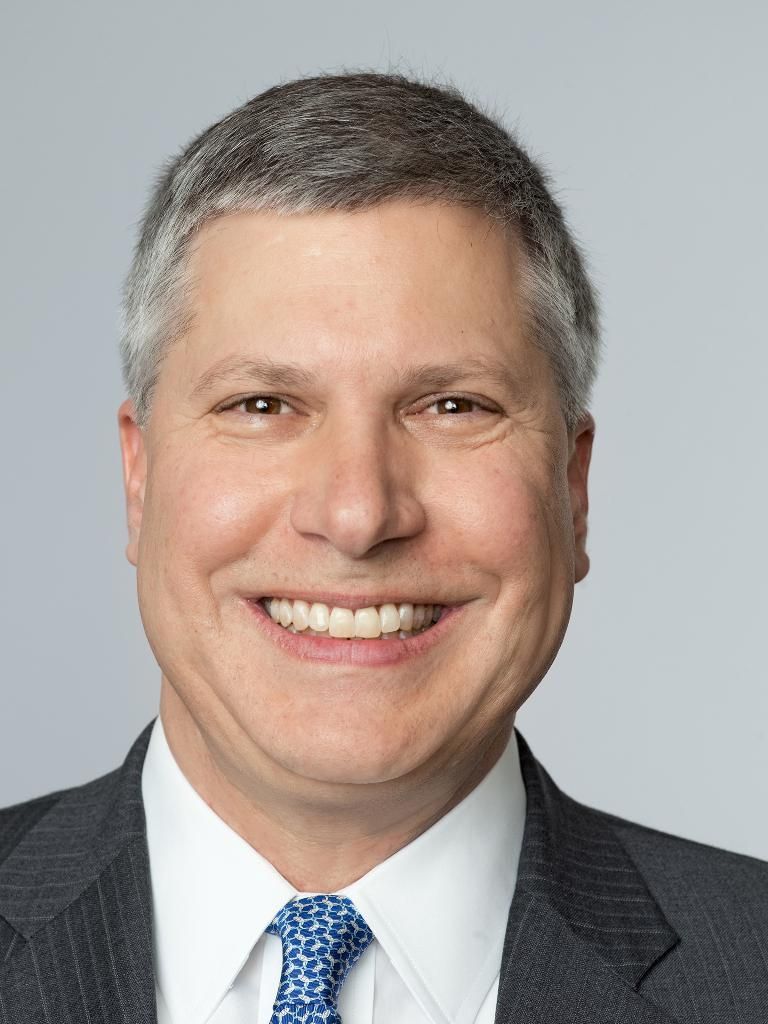Who is present in the image? There is a man in the image. What is the man wearing? The man is wearing a suit. What is the man's facial expression? The man is smiling. What color is the background of the image? The background of the image is white. Can you hear the man's mom crying in the image? There is no sound in the image, and there is no indication of a mom or crying. 